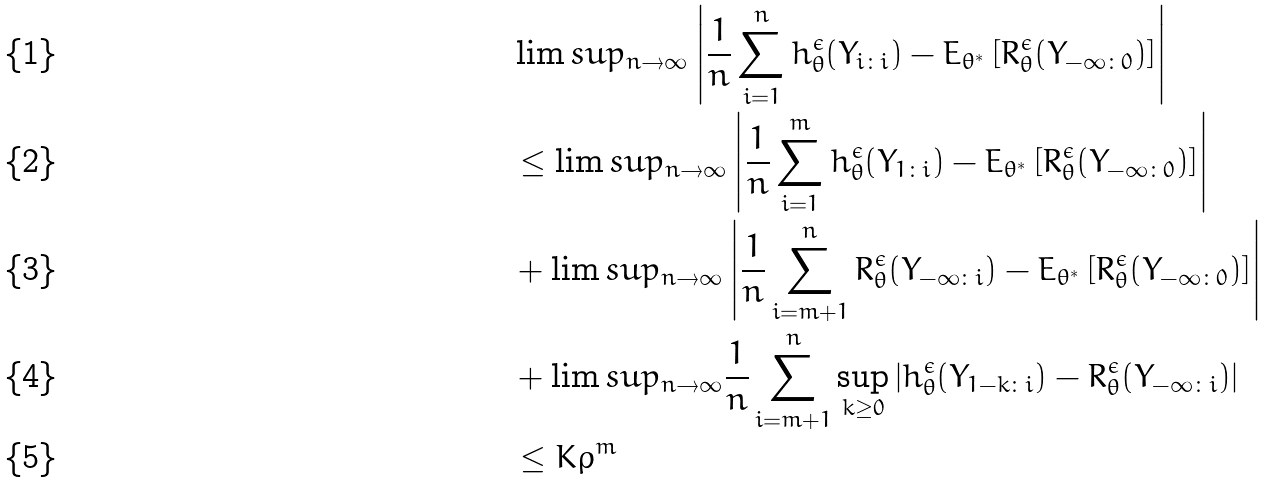<formula> <loc_0><loc_0><loc_500><loc_500>& \lim s u p _ { n \to \infty } \left | \frac { 1 } { n } \sum _ { i = 1 } ^ { n } h ^ { \epsilon } _ { \theta } ( Y _ { i \colon i } ) - E _ { \theta ^ { \ast } } \left [ R ^ { \epsilon } _ { \theta } ( Y _ { - \infty \colon 0 } ) \right ] \right | \\ & \leq \lim s u p _ { n \to \infty } \left | \frac { 1 } { n } \sum _ { i = 1 } ^ { m } h ^ { \epsilon } _ { \theta } ( Y _ { 1 \colon i } ) - E _ { \theta ^ { \ast } } \left [ R ^ { \epsilon } _ { \theta } ( Y _ { - \infty \colon 0 } ) \right ] \right | \\ & + \lim s u p _ { n \to \infty } \left | \frac { 1 } { n } \sum _ { i = m + 1 } ^ { n } R ^ { \epsilon } _ { \theta } ( Y _ { - \infty \colon i } ) - E _ { \theta ^ { \ast } } \left [ R ^ { \epsilon } _ { \theta } ( Y _ { - \infty \colon 0 } ) \right ] \right | \\ & + \lim s u p _ { n \to \infty } \frac { 1 } { n } \sum _ { i = m + 1 } ^ { n } \sup _ { k \geq 0 } \left | h ^ { \epsilon } _ { \theta } ( Y _ { 1 - k \colon i } ) - R ^ { \epsilon } _ { \theta } ( Y _ { - \infty \colon i } ) \right | \\ & \leq K \rho ^ { m }</formula> 